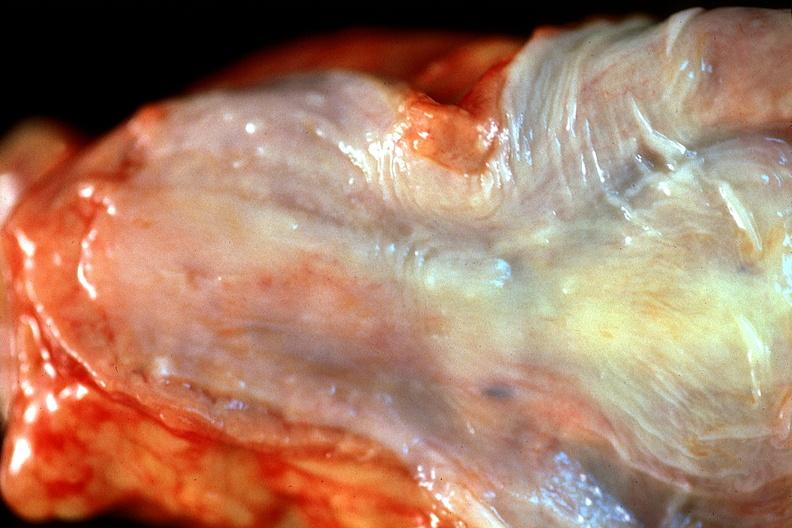where does this belong to?
Answer the question using a single word or phrase. Gastrointestinal system 